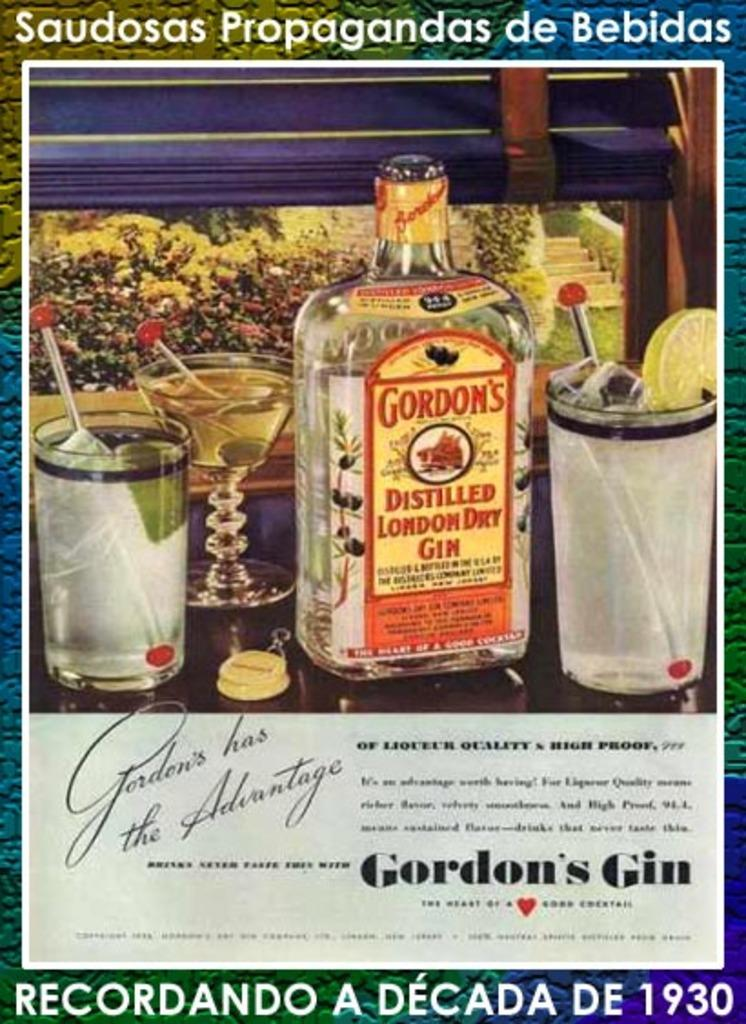<image>
Give a short and clear explanation of the subsequent image. An advertisement for Gordon's distilled London dry gin 